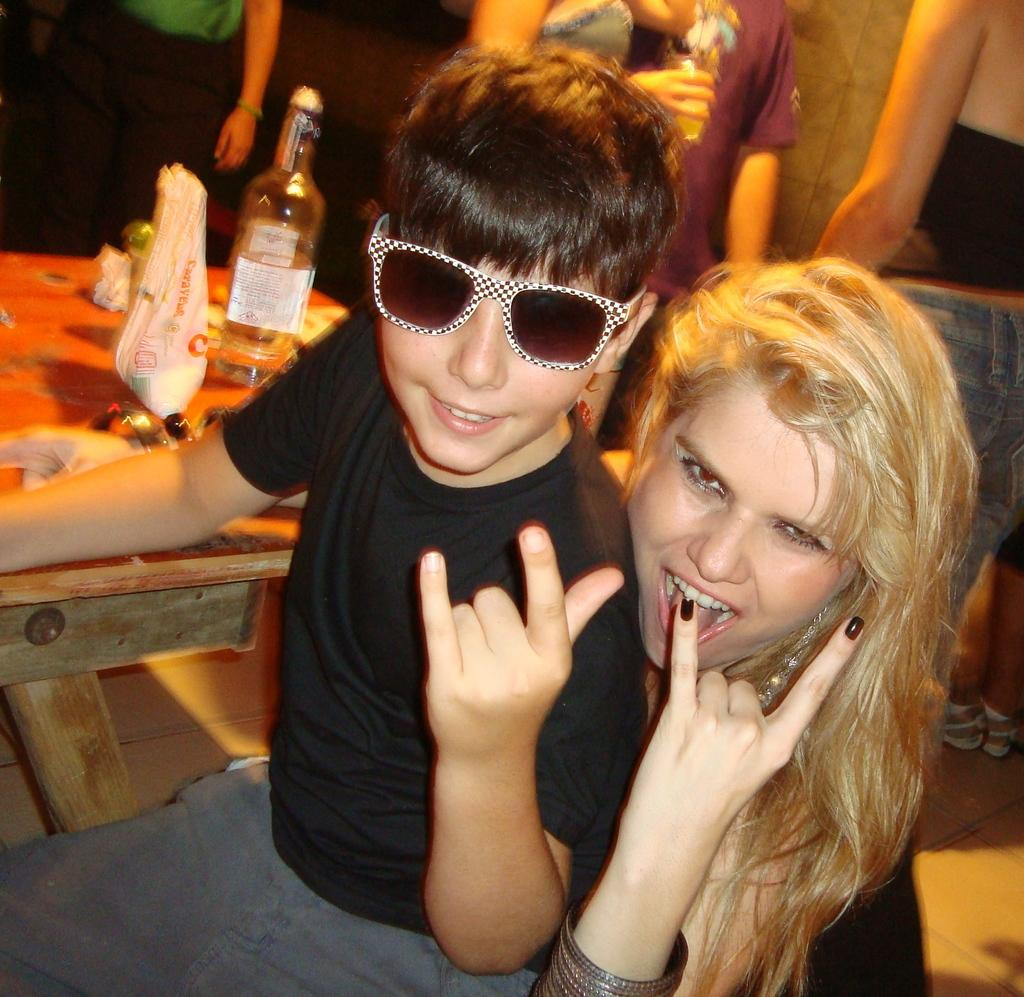Who are the people in the image? There is a lady and a boy in the image. What is the boy wearing? The boy is wearing goggles. What can be seen in the background of the image? There is a table in the background of the image. What is on the table? There is a bottle and other items on the table. Are there any other people visible in the image? Yes, there are people in the background of the image. What type of sail can be seen on the river in the image? There is no sail or river present in the image; it features a lady, a boy, and a table with items. 